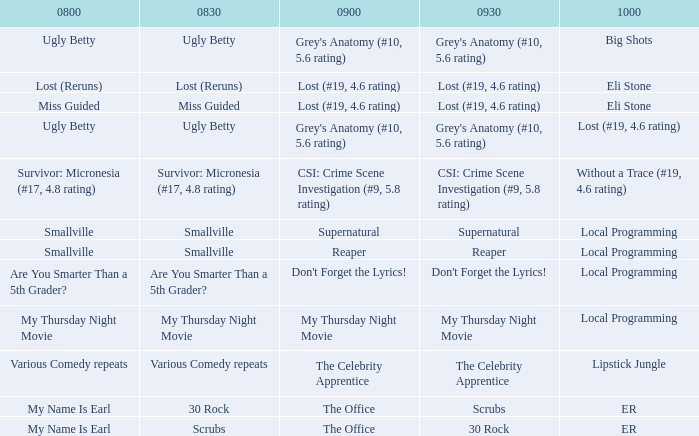What is at 10:00 when at 9:00 it is lost (#19, 4.6 rating) and at 8:30 it is lost (reruns)? Eli Stone. 